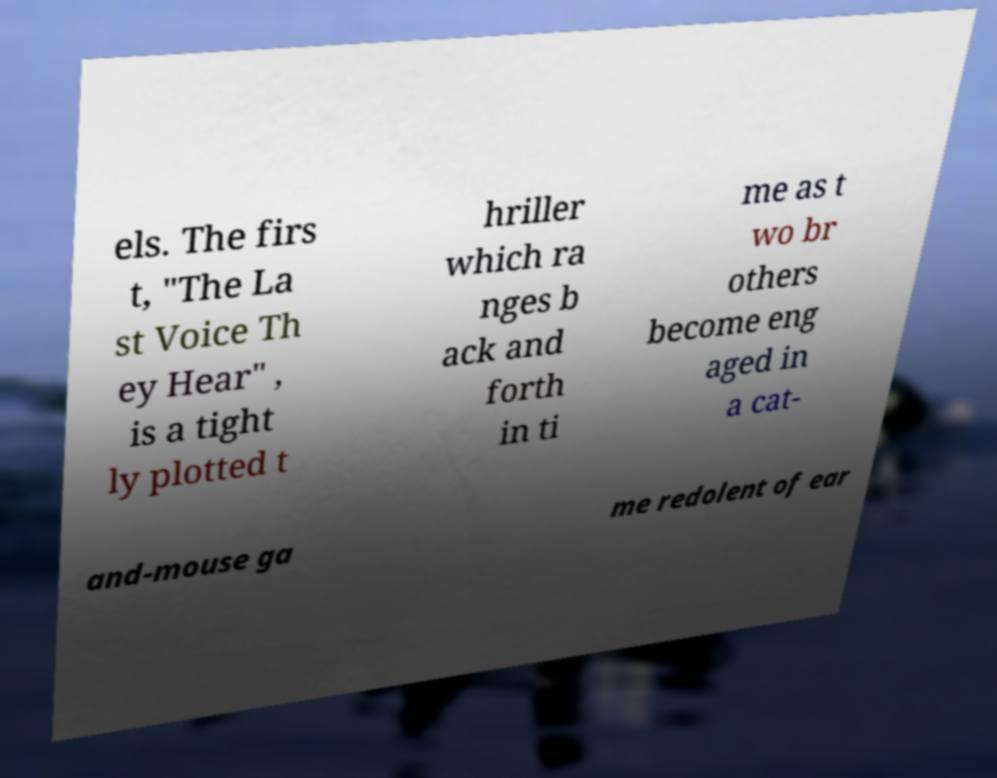Please read and relay the text visible in this image. What does it say? els. The firs t, "The La st Voice Th ey Hear" , is a tight ly plotted t hriller which ra nges b ack and forth in ti me as t wo br others become eng aged in a cat- and-mouse ga me redolent of ear 